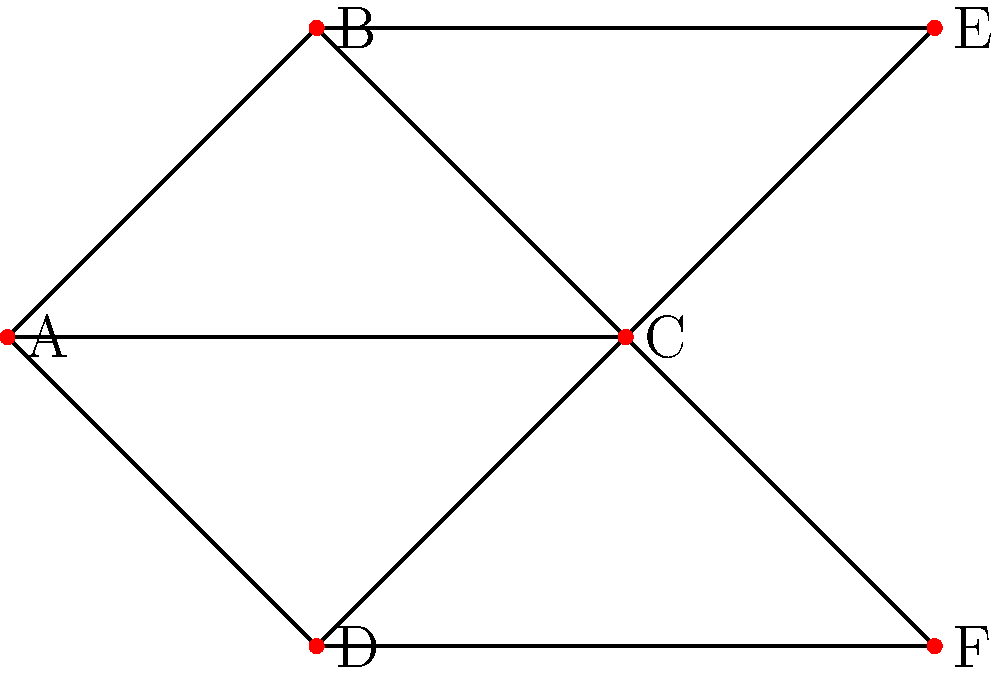In a pharmaceutical distribution network, each node represents a pharmacy, and edges represent direct supply routes between pharmacies. Using the concept of degree centrality, which pharmacy in the given network is most central and likely to be the most efficient hub for drug distribution? To solve this problem, we need to calculate the degree centrality for each pharmacy in the network. Degree centrality is a measure of the number of direct connections a node has to other nodes in the network.

Step 1: Count the number of connections (degree) for each pharmacy:
A: 3 connections
B: 3 connections
C: 5 connections
D: 3 connections
E: 2 connections
F: 2 connections

Step 2: Identify the pharmacy with the highest degree:
Pharmacy C has the highest degree with 5 connections.

Step 3: Interpret the result:
The pharmacy with the highest degree centrality (Pharmacy C) is considered the most central in the network. This means it has the most direct connections to other pharmacies, making it the most efficient hub for drug distribution.

In the context of pharmaceutical distribution, Pharmacy C would be the best location for:
1. Storing a larger inventory of drugs
2. Redistributing medications to other pharmacies in the network
3. Receiving new shipments for further distribution
4. Coordinating supply chain activities

This central position could potentially help in reducing distribution costs and improving the efficiency of drug delivery throughout the network.
Answer: Pharmacy C 